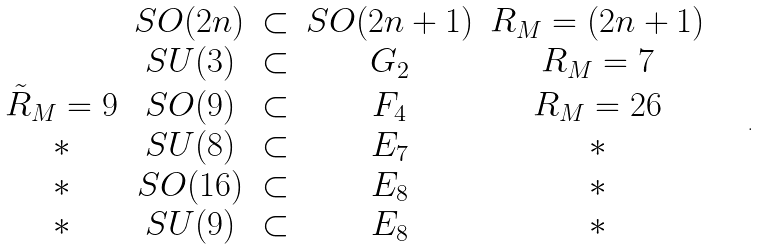Convert formula to latex. <formula><loc_0><loc_0><loc_500><loc_500>\begin{array} { c c c c c } & S O ( 2 n ) & \subset & S O ( 2 n + 1 ) & R _ { M } = { ( 2 n + 1 ) } \\ & S U ( 3 ) & \subset & G _ { 2 } & R _ { M } = { 7 } \\ \tilde { R } _ { M } = { 9 } & S O ( 9 ) & \subset & F _ { 4 } & R _ { M } = { 2 6 } \\ \ast & S U ( 8 ) & \subset & E _ { 7 } & \ast \\ \ast & S O ( 1 6 ) & \subset & E _ { 8 } & \ast \\ \ast & S U ( 9 ) & \subset & E _ { 8 } & \ast \end{array} \quad .</formula> 